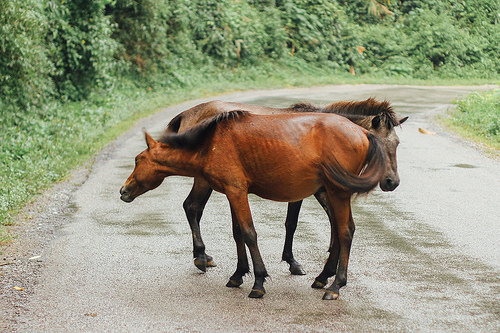<image>
Is the horse under the horse? No. The horse is not positioned under the horse. The vertical relationship between these objects is different. Is there a road in front of the horse? Yes. The road is positioned in front of the horse, appearing closer to the camera viewpoint. 